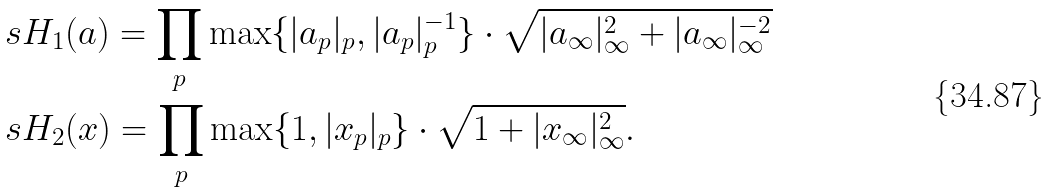<formula> <loc_0><loc_0><loc_500><loc_500>& \ s H _ { 1 } ( a ) = \prod _ { p } \max \{ | a _ { p } | _ { p } , | a _ { p } | _ { p } ^ { - 1 } \} \cdot \sqrt { | a _ { \infty } | _ { \infty } ^ { 2 } + | a _ { \infty } | _ { \infty } ^ { - 2 } } \\ & \ s H _ { 2 } ( x ) = \prod _ { p } \max \{ 1 , | x _ { p } | _ { p } \} \cdot \sqrt { 1 + | x _ { \infty } | _ { \infty } ^ { 2 } } .</formula> 